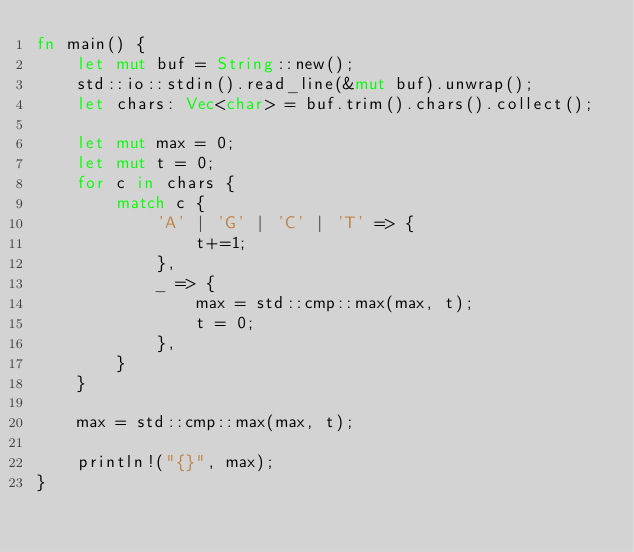<code> <loc_0><loc_0><loc_500><loc_500><_Rust_>fn main() {
    let mut buf = String::new();
    std::io::stdin().read_line(&mut buf).unwrap();
    let chars: Vec<char> = buf.trim().chars().collect();

    let mut max = 0;
    let mut t = 0;
    for c in chars {
        match c {
            'A' | 'G' | 'C' | 'T' => {
                t+=1;
            },
            _ => {
                max = std::cmp::max(max, t);
                t = 0;
            },
        }
    }

    max = std::cmp::max(max, t);

    println!("{}", max);
}
</code> 